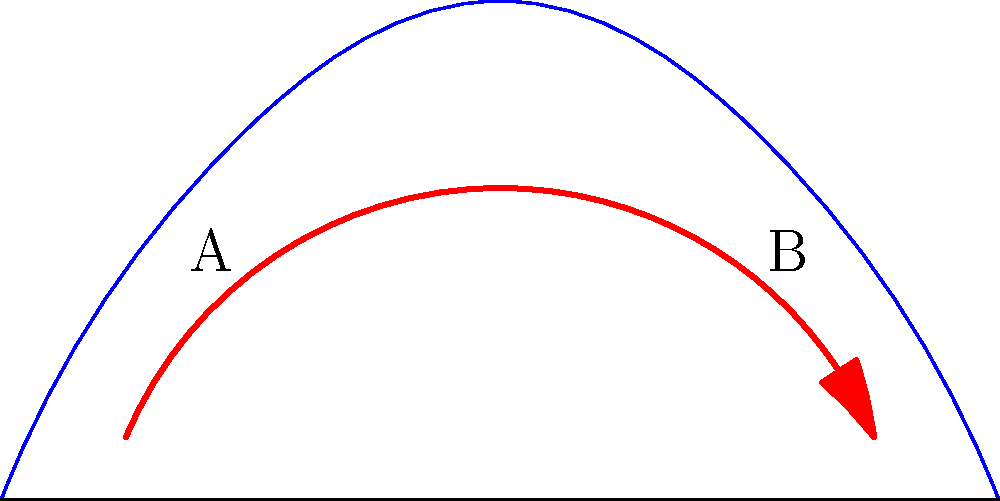Based on the cross-sectional diagram of the nasal passages shown above, which region (A or B) experiences higher air velocity during inhalation, assuming equal air volume passes through both sides? To determine which region experiences higher air velocity, we need to consider the principles of fluid dynamics and the anatomy of the nasal passages:

1. Continuity equation: The volume flow rate (Q) remains constant throughout the passage. Q = velocity (v) × cross-sectional area (A).

2. Observe the diagram:
   - Region A has a wider cross-sectional area.
   - Region B has a narrower cross-sectional area.

3. Apply the continuity equation:
   $Q_A = v_A \times A_A = Q_B = v_B \times A_B$

4. Since the volume flow rate (Q) is constant:
   $v_A \times A_A = v_B \times A_B$

5. Rearrange the equation:
   $v_B = v_A \times (A_A / A_B)$

6. As $A_A > A_B$, we can conclude that $v_B > v_A$

Therefore, the air velocity is higher in the narrower region B compared to the wider region A.
Answer: B 